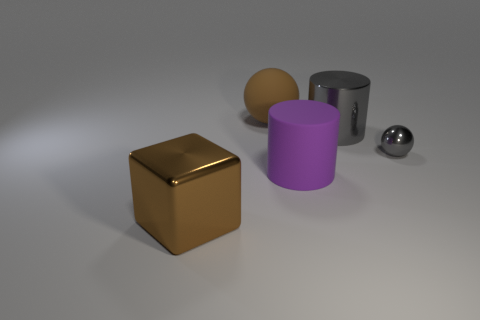What is the big thing that is both on the right side of the cube and in front of the tiny sphere made of?
Ensure brevity in your answer.  Rubber. Is there any other thing that has the same shape as the brown shiny object?
Make the answer very short. No. Does the big cylinder that is behind the large purple rubber object have the same material as the large brown sphere?
Your answer should be very brief. No. What material is the purple thing right of the matte ball?
Offer a very short reply. Rubber. What size is the sphere to the right of the big cylinder to the left of the large gray metal cylinder?
Provide a short and direct response. Small. What number of gray shiny things are the same size as the block?
Make the answer very short. 1. There is a sphere left of the purple rubber cylinder; is it the same color as the metallic object in front of the big purple thing?
Provide a succinct answer. Yes. There is a rubber sphere; are there any tiny gray metal things behind it?
Keep it short and to the point. No. What is the color of the thing that is both behind the tiny gray sphere and right of the large purple object?
Your response must be concise. Gray. Is there a large thing of the same color as the cube?
Keep it short and to the point. Yes. 